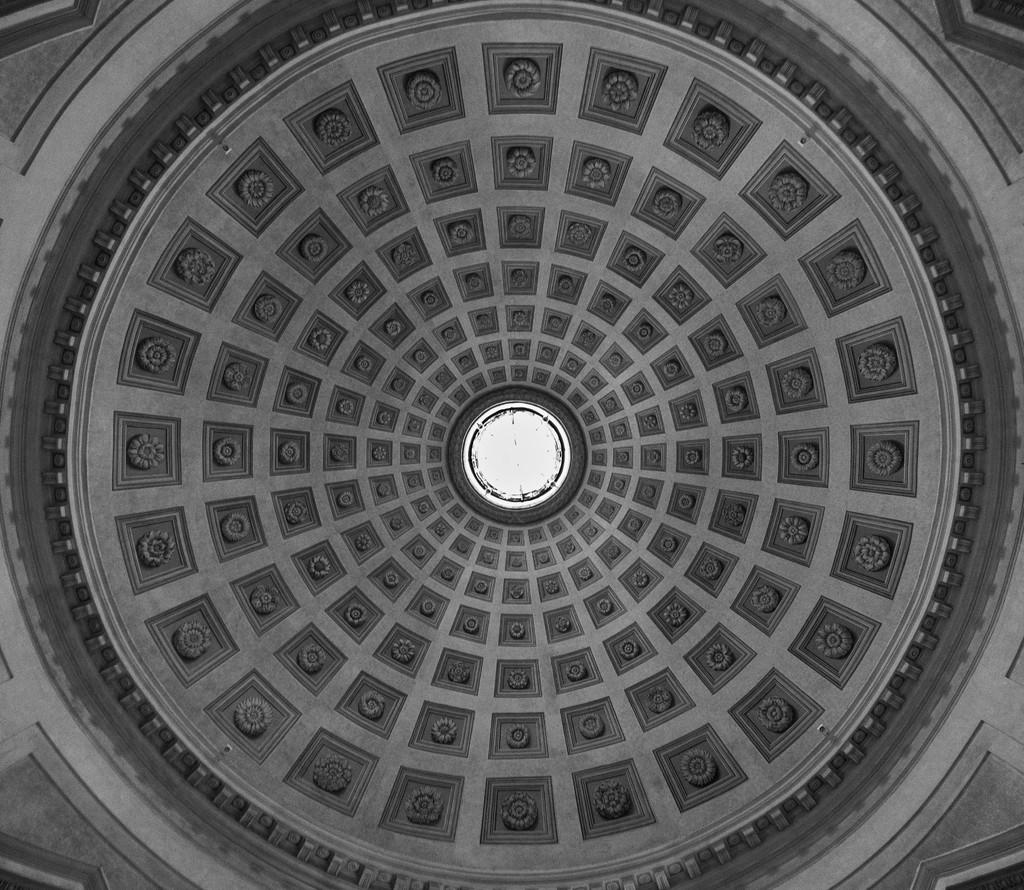What is present in the image that covers the top of a structure? There is a roof in the image. Can you describe the appearance of the roof? The roof has a design. Where is the drawer located in the image? There is no drawer present in the image. What type of fish can be seen swimming near the roof in the image? There are no fish present in the image; it only features a roof with a design. 